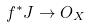<formula> <loc_0><loc_0><loc_500><loc_500>f ^ { * } J \rightarrow O _ { X }</formula> 